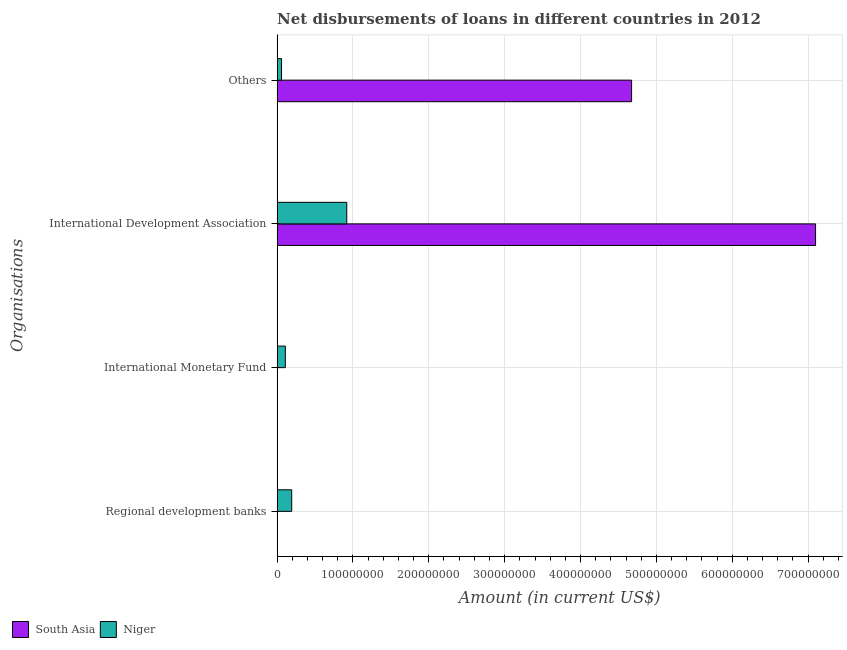Are the number of bars per tick equal to the number of legend labels?
Provide a short and direct response. No. Are the number of bars on each tick of the Y-axis equal?
Keep it short and to the point. No. How many bars are there on the 4th tick from the top?
Your answer should be very brief. 1. How many bars are there on the 1st tick from the bottom?
Provide a succinct answer. 1. What is the label of the 4th group of bars from the top?
Offer a terse response. Regional development banks. What is the amount of loan disimbursed by other organisations in South Asia?
Provide a short and direct response. 4.67e+08. Across all countries, what is the maximum amount of loan disimbursed by regional development banks?
Your response must be concise. 1.92e+07. In which country was the amount of loan disimbursed by other organisations maximum?
Keep it short and to the point. South Asia. What is the total amount of loan disimbursed by other organisations in the graph?
Give a very brief answer. 4.73e+08. What is the difference between the amount of loan disimbursed by other organisations in Niger and that in South Asia?
Your response must be concise. -4.62e+08. What is the difference between the amount of loan disimbursed by international monetary fund in South Asia and the amount of loan disimbursed by other organisations in Niger?
Ensure brevity in your answer.  -5.78e+06. What is the average amount of loan disimbursed by regional development banks per country?
Offer a terse response. 9.61e+06. What is the difference between the amount of loan disimbursed by other organisations and amount of loan disimbursed by international monetary fund in Niger?
Give a very brief answer. -5.02e+06. What is the ratio of the amount of loan disimbursed by other organisations in South Asia to that in Niger?
Offer a very short reply. 80.84. What is the difference between the highest and the second highest amount of loan disimbursed by international development association?
Keep it short and to the point. 6.18e+08. What is the difference between the highest and the lowest amount of loan disimbursed by other organisations?
Make the answer very short. 4.62e+08. In how many countries, is the amount of loan disimbursed by other organisations greater than the average amount of loan disimbursed by other organisations taken over all countries?
Ensure brevity in your answer.  1. Is the sum of the amount of loan disimbursed by other organisations in Niger and South Asia greater than the maximum amount of loan disimbursed by international monetary fund across all countries?
Your response must be concise. Yes. Is it the case that in every country, the sum of the amount of loan disimbursed by regional development banks and amount of loan disimbursed by international monetary fund is greater than the amount of loan disimbursed by international development association?
Ensure brevity in your answer.  No. What is the difference between two consecutive major ticks on the X-axis?
Your response must be concise. 1.00e+08. Are the values on the major ticks of X-axis written in scientific E-notation?
Give a very brief answer. No. Where does the legend appear in the graph?
Your response must be concise. Bottom left. What is the title of the graph?
Give a very brief answer. Net disbursements of loans in different countries in 2012. What is the label or title of the Y-axis?
Your answer should be very brief. Organisations. What is the Amount (in current US$) of South Asia in Regional development banks?
Your answer should be very brief. 0. What is the Amount (in current US$) in Niger in Regional development banks?
Make the answer very short. 1.92e+07. What is the Amount (in current US$) of South Asia in International Monetary Fund?
Keep it short and to the point. 0. What is the Amount (in current US$) of Niger in International Monetary Fund?
Your response must be concise. 1.08e+07. What is the Amount (in current US$) in South Asia in International Development Association?
Offer a terse response. 7.10e+08. What is the Amount (in current US$) of Niger in International Development Association?
Your answer should be compact. 9.18e+07. What is the Amount (in current US$) in South Asia in Others?
Make the answer very short. 4.67e+08. What is the Amount (in current US$) of Niger in Others?
Your response must be concise. 5.78e+06. Across all Organisations, what is the maximum Amount (in current US$) in South Asia?
Offer a terse response. 7.10e+08. Across all Organisations, what is the maximum Amount (in current US$) of Niger?
Keep it short and to the point. 9.18e+07. Across all Organisations, what is the minimum Amount (in current US$) in South Asia?
Your answer should be compact. 0. Across all Organisations, what is the minimum Amount (in current US$) of Niger?
Give a very brief answer. 5.78e+06. What is the total Amount (in current US$) of South Asia in the graph?
Provide a short and direct response. 1.18e+09. What is the total Amount (in current US$) in Niger in the graph?
Your answer should be very brief. 1.28e+08. What is the difference between the Amount (in current US$) of Niger in Regional development banks and that in International Monetary Fund?
Offer a terse response. 8.42e+06. What is the difference between the Amount (in current US$) of Niger in Regional development banks and that in International Development Association?
Your answer should be very brief. -7.26e+07. What is the difference between the Amount (in current US$) of Niger in Regional development banks and that in Others?
Your response must be concise. 1.34e+07. What is the difference between the Amount (in current US$) of Niger in International Monetary Fund and that in International Development Association?
Provide a short and direct response. -8.10e+07. What is the difference between the Amount (in current US$) in Niger in International Monetary Fund and that in Others?
Your answer should be very brief. 5.02e+06. What is the difference between the Amount (in current US$) in South Asia in International Development Association and that in Others?
Provide a succinct answer. 2.43e+08. What is the difference between the Amount (in current US$) in Niger in International Development Association and that in Others?
Keep it short and to the point. 8.60e+07. What is the difference between the Amount (in current US$) of South Asia in International Development Association and the Amount (in current US$) of Niger in Others?
Give a very brief answer. 7.04e+08. What is the average Amount (in current US$) in South Asia per Organisations?
Offer a terse response. 2.94e+08. What is the average Amount (in current US$) in Niger per Organisations?
Provide a succinct answer. 3.19e+07. What is the difference between the Amount (in current US$) in South Asia and Amount (in current US$) in Niger in International Development Association?
Your answer should be compact. 6.18e+08. What is the difference between the Amount (in current US$) in South Asia and Amount (in current US$) in Niger in Others?
Keep it short and to the point. 4.62e+08. What is the ratio of the Amount (in current US$) of Niger in Regional development banks to that in International Monetary Fund?
Your answer should be very brief. 1.78. What is the ratio of the Amount (in current US$) in Niger in Regional development banks to that in International Development Association?
Provide a short and direct response. 0.21. What is the ratio of the Amount (in current US$) in Niger in Regional development banks to that in Others?
Your response must be concise. 3.33. What is the ratio of the Amount (in current US$) of Niger in International Monetary Fund to that in International Development Association?
Your response must be concise. 0.12. What is the ratio of the Amount (in current US$) of Niger in International Monetary Fund to that in Others?
Your answer should be very brief. 1.87. What is the ratio of the Amount (in current US$) in South Asia in International Development Association to that in Others?
Your answer should be compact. 1.52. What is the ratio of the Amount (in current US$) of Niger in International Development Association to that in Others?
Ensure brevity in your answer.  15.88. What is the difference between the highest and the second highest Amount (in current US$) of Niger?
Give a very brief answer. 7.26e+07. What is the difference between the highest and the lowest Amount (in current US$) in South Asia?
Offer a terse response. 7.10e+08. What is the difference between the highest and the lowest Amount (in current US$) of Niger?
Your answer should be very brief. 8.60e+07. 